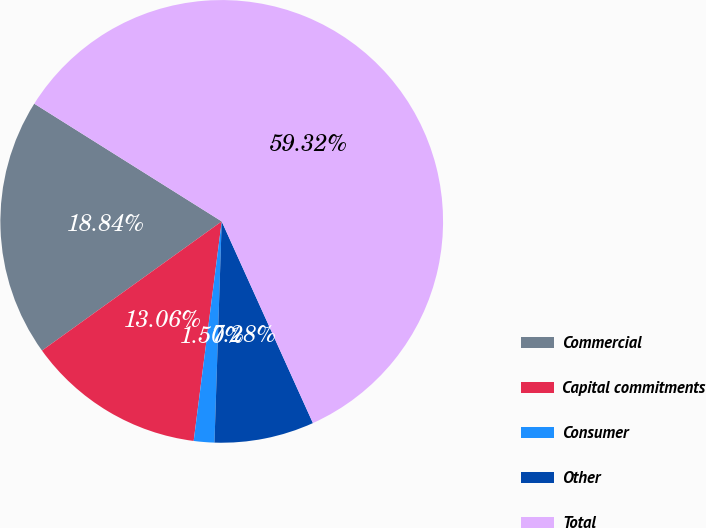<chart> <loc_0><loc_0><loc_500><loc_500><pie_chart><fcel>Commercial<fcel>Capital commitments<fcel>Consumer<fcel>Other<fcel>Total<nl><fcel>18.84%<fcel>13.06%<fcel>1.5%<fcel>7.28%<fcel>59.31%<nl></chart> 